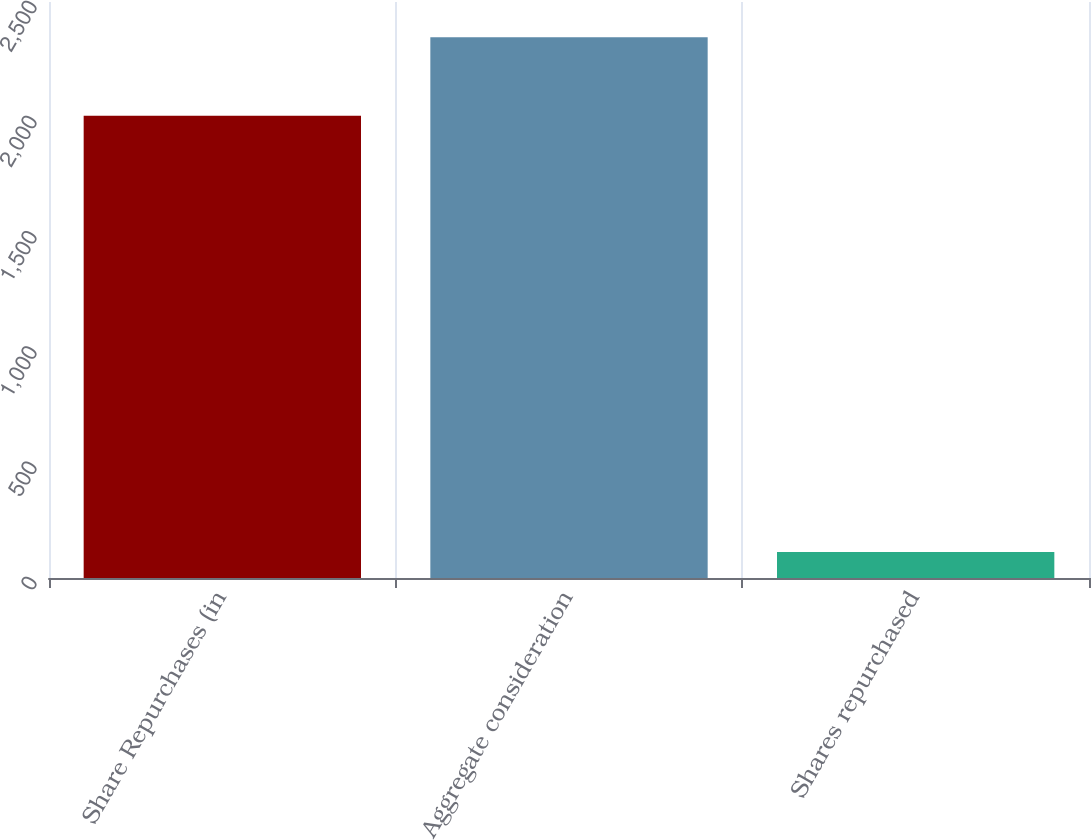<chart> <loc_0><loc_0><loc_500><loc_500><bar_chart><fcel>Share Repurchases (in<fcel>Aggregate consideration<fcel>Shares repurchased<nl><fcel>2006<fcel>2347<fcel>113<nl></chart> 